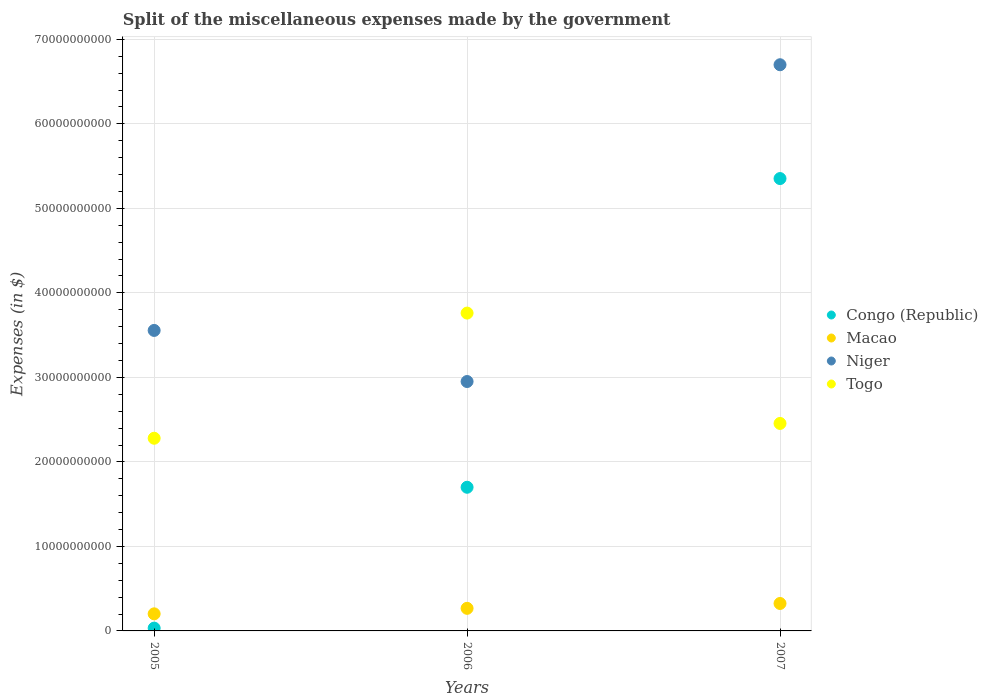How many different coloured dotlines are there?
Offer a very short reply. 4. Is the number of dotlines equal to the number of legend labels?
Give a very brief answer. Yes. What is the miscellaneous expenses made by the government in Macao in 2005?
Your answer should be very brief. 2.02e+09. Across all years, what is the maximum miscellaneous expenses made by the government in Niger?
Ensure brevity in your answer.  6.70e+1. Across all years, what is the minimum miscellaneous expenses made by the government in Congo (Republic)?
Ensure brevity in your answer.  3.32e+08. What is the total miscellaneous expenses made by the government in Niger in the graph?
Give a very brief answer. 1.32e+11. What is the difference between the miscellaneous expenses made by the government in Macao in 2005 and that in 2007?
Your answer should be compact. -1.23e+09. What is the difference between the miscellaneous expenses made by the government in Niger in 2005 and the miscellaneous expenses made by the government in Togo in 2007?
Provide a short and direct response. 1.10e+1. What is the average miscellaneous expenses made by the government in Niger per year?
Give a very brief answer. 4.40e+1. In the year 2006, what is the difference between the miscellaneous expenses made by the government in Macao and miscellaneous expenses made by the government in Togo?
Your response must be concise. -3.49e+1. What is the ratio of the miscellaneous expenses made by the government in Togo in 2006 to that in 2007?
Offer a terse response. 1.53. Is the difference between the miscellaneous expenses made by the government in Macao in 2005 and 2006 greater than the difference between the miscellaneous expenses made by the government in Togo in 2005 and 2006?
Provide a succinct answer. Yes. What is the difference between the highest and the second highest miscellaneous expenses made by the government in Congo (Republic)?
Ensure brevity in your answer.  3.65e+1. What is the difference between the highest and the lowest miscellaneous expenses made by the government in Togo?
Provide a short and direct response. 1.48e+1. Is it the case that in every year, the sum of the miscellaneous expenses made by the government in Congo (Republic) and miscellaneous expenses made by the government in Niger  is greater than the sum of miscellaneous expenses made by the government in Togo and miscellaneous expenses made by the government in Macao?
Provide a succinct answer. No. Is it the case that in every year, the sum of the miscellaneous expenses made by the government in Togo and miscellaneous expenses made by the government in Niger  is greater than the miscellaneous expenses made by the government in Congo (Republic)?
Offer a very short reply. Yes. Is the miscellaneous expenses made by the government in Niger strictly greater than the miscellaneous expenses made by the government in Congo (Republic) over the years?
Your answer should be very brief. Yes. Is the miscellaneous expenses made by the government in Niger strictly less than the miscellaneous expenses made by the government in Macao over the years?
Keep it short and to the point. No. How many years are there in the graph?
Keep it short and to the point. 3. What is the difference between two consecutive major ticks on the Y-axis?
Ensure brevity in your answer.  1.00e+1. Where does the legend appear in the graph?
Keep it short and to the point. Center right. How are the legend labels stacked?
Your response must be concise. Vertical. What is the title of the graph?
Provide a short and direct response. Split of the miscellaneous expenses made by the government. What is the label or title of the Y-axis?
Your answer should be very brief. Expenses (in $). What is the Expenses (in $) of Congo (Republic) in 2005?
Offer a terse response. 3.32e+08. What is the Expenses (in $) of Macao in 2005?
Keep it short and to the point. 2.02e+09. What is the Expenses (in $) in Niger in 2005?
Offer a very short reply. 3.56e+1. What is the Expenses (in $) of Togo in 2005?
Ensure brevity in your answer.  2.28e+1. What is the Expenses (in $) of Congo (Republic) in 2006?
Provide a short and direct response. 1.70e+1. What is the Expenses (in $) of Macao in 2006?
Your answer should be very brief. 2.67e+09. What is the Expenses (in $) of Niger in 2006?
Your answer should be compact. 2.95e+1. What is the Expenses (in $) of Togo in 2006?
Your response must be concise. 3.76e+1. What is the Expenses (in $) in Congo (Republic) in 2007?
Your answer should be very brief. 5.35e+1. What is the Expenses (in $) in Macao in 2007?
Make the answer very short. 3.25e+09. What is the Expenses (in $) in Niger in 2007?
Make the answer very short. 6.70e+1. What is the Expenses (in $) in Togo in 2007?
Provide a short and direct response. 2.46e+1. Across all years, what is the maximum Expenses (in $) in Congo (Republic)?
Your answer should be very brief. 5.35e+1. Across all years, what is the maximum Expenses (in $) in Macao?
Give a very brief answer. 3.25e+09. Across all years, what is the maximum Expenses (in $) in Niger?
Your answer should be very brief. 6.70e+1. Across all years, what is the maximum Expenses (in $) of Togo?
Provide a short and direct response. 3.76e+1. Across all years, what is the minimum Expenses (in $) of Congo (Republic)?
Your response must be concise. 3.32e+08. Across all years, what is the minimum Expenses (in $) of Macao?
Your answer should be compact. 2.02e+09. Across all years, what is the minimum Expenses (in $) in Niger?
Offer a very short reply. 2.95e+1. Across all years, what is the minimum Expenses (in $) in Togo?
Ensure brevity in your answer.  2.28e+1. What is the total Expenses (in $) of Congo (Republic) in the graph?
Make the answer very short. 7.09e+1. What is the total Expenses (in $) in Macao in the graph?
Your answer should be very brief. 7.94e+09. What is the total Expenses (in $) of Niger in the graph?
Provide a short and direct response. 1.32e+11. What is the total Expenses (in $) of Togo in the graph?
Your response must be concise. 8.50e+1. What is the difference between the Expenses (in $) in Congo (Republic) in 2005 and that in 2006?
Your response must be concise. -1.67e+1. What is the difference between the Expenses (in $) in Macao in 2005 and that in 2006?
Your response must be concise. -6.51e+08. What is the difference between the Expenses (in $) in Niger in 2005 and that in 2006?
Provide a succinct answer. 6.05e+09. What is the difference between the Expenses (in $) of Togo in 2005 and that in 2006?
Provide a short and direct response. -1.48e+1. What is the difference between the Expenses (in $) of Congo (Republic) in 2005 and that in 2007?
Your answer should be compact. -5.32e+1. What is the difference between the Expenses (in $) in Macao in 2005 and that in 2007?
Offer a very short reply. -1.23e+09. What is the difference between the Expenses (in $) in Niger in 2005 and that in 2007?
Make the answer very short. -3.14e+1. What is the difference between the Expenses (in $) in Togo in 2005 and that in 2007?
Keep it short and to the point. -1.75e+09. What is the difference between the Expenses (in $) of Congo (Republic) in 2006 and that in 2007?
Keep it short and to the point. -3.65e+1. What is the difference between the Expenses (in $) in Macao in 2006 and that in 2007?
Your response must be concise. -5.74e+08. What is the difference between the Expenses (in $) in Niger in 2006 and that in 2007?
Your answer should be very brief. -3.75e+1. What is the difference between the Expenses (in $) of Togo in 2006 and that in 2007?
Offer a terse response. 1.31e+1. What is the difference between the Expenses (in $) in Congo (Republic) in 2005 and the Expenses (in $) in Macao in 2006?
Provide a succinct answer. -2.34e+09. What is the difference between the Expenses (in $) in Congo (Republic) in 2005 and the Expenses (in $) in Niger in 2006?
Ensure brevity in your answer.  -2.92e+1. What is the difference between the Expenses (in $) of Congo (Republic) in 2005 and the Expenses (in $) of Togo in 2006?
Your response must be concise. -3.73e+1. What is the difference between the Expenses (in $) in Macao in 2005 and the Expenses (in $) in Niger in 2006?
Your response must be concise. -2.75e+1. What is the difference between the Expenses (in $) of Macao in 2005 and the Expenses (in $) of Togo in 2006?
Your answer should be very brief. -3.56e+1. What is the difference between the Expenses (in $) of Niger in 2005 and the Expenses (in $) of Togo in 2006?
Keep it short and to the point. -2.05e+09. What is the difference between the Expenses (in $) in Congo (Republic) in 2005 and the Expenses (in $) in Macao in 2007?
Keep it short and to the point. -2.91e+09. What is the difference between the Expenses (in $) in Congo (Republic) in 2005 and the Expenses (in $) in Niger in 2007?
Offer a very short reply. -6.67e+1. What is the difference between the Expenses (in $) in Congo (Republic) in 2005 and the Expenses (in $) in Togo in 2007?
Make the answer very short. -2.42e+1. What is the difference between the Expenses (in $) in Macao in 2005 and the Expenses (in $) in Niger in 2007?
Make the answer very short. -6.50e+1. What is the difference between the Expenses (in $) in Macao in 2005 and the Expenses (in $) in Togo in 2007?
Offer a terse response. -2.25e+1. What is the difference between the Expenses (in $) of Niger in 2005 and the Expenses (in $) of Togo in 2007?
Provide a short and direct response. 1.10e+1. What is the difference between the Expenses (in $) in Congo (Republic) in 2006 and the Expenses (in $) in Macao in 2007?
Provide a short and direct response. 1.38e+1. What is the difference between the Expenses (in $) of Congo (Republic) in 2006 and the Expenses (in $) of Niger in 2007?
Your answer should be compact. -5.00e+1. What is the difference between the Expenses (in $) of Congo (Republic) in 2006 and the Expenses (in $) of Togo in 2007?
Offer a very short reply. -7.55e+09. What is the difference between the Expenses (in $) of Macao in 2006 and the Expenses (in $) of Niger in 2007?
Make the answer very short. -6.43e+1. What is the difference between the Expenses (in $) in Macao in 2006 and the Expenses (in $) in Togo in 2007?
Give a very brief answer. -2.19e+1. What is the difference between the Expenses (in $) of Niger in 2006 and the Expenses (in $) of Togo in 2007?
Give a very brief answer. 4.96e+09. What is the average Expenses (in $) of Congo (Republic) per year?
Your answer should be compact. 2.36e+1. What is the average Expenses (in $) of Macao per year?
Your answer should be compact. 2.65e+09. What is the average Expenses (in $) in Niger per year?
Offer a terse response. 4.40e+1. What is the average Expenses (in $) of Togo per year?
Ensure brevity in your answer.  2.83e+1. In the year 2005, what is the difference between the Expenses (in $) in Congo (Republic) and Expenses (in $) in Macao?
Keep it short and to the point. -1.69e+09. In the year 2005, what is the difference between the Expenses (in $) in Congo (Republic) and Expenses (in $) in Niger?
Offer a terse response. -3.52e+1. In the year 2005, what is the difference between the Expenses (in $) of Congo (Republic) and Expenses (in $) of Togo?
Keep it short and to the point. -2.25e+1. In the year 2005, what is the difference between the Expenses (in $) of Macao and Expenses (in $) of Niger?
Keep it short and to the point. -3.35e+1. In the year 2005, what is the difference between the Expenses (in $) of Macao and Expenses (in $) of Togo?
Make the answer very short. -2.08e+1. In the year 2005, what is the difference between the Expenses (in $) in Niger and Expenses (in $) in Togo?
Give a very brief answer. 1.28e+1. In the year 2006, what is the difference between the Expenses (in $) in Congo (Republic) and Expenses (in $) in Macao?
Give a very brief answer. 1.43e+1. In the year 2006, what is the difference between the Expenses (in $) of Congo (Republic) and Expenses (in $) of Niger?
Provide a short and direct response. -1.25e+1. In the year 2006, what is the difference between the Expenses (in $) in Congo (Republic) and Expenses (in $) in Togo?
Ensure brevity in your answer.  -2.06e+1. In the year 2006, what is the difference between the Expenses (in $) in Macao and Expenses (in $) in Niger?
Your response must be concise. -2.68e+1. In the year 2006, what is the difference between the Expenses (in $) of Macao and Expenses (in $) of Togo?
Provide a succinct answer. -3.49e+1. In the year 2006, what is the difference between the Expenses (in $) of Niger and Expenses (in $) of Togo?
Your answer should be compact. -8.10e+09. In the year 2007, what is the difference between the Expenses (in $) in Congo (Republic) and Expenses (in $) in Macao?
Keep it short and to the point. 5.03e+1. In the year 2007, what is the difference between the Expenses (in $) of Congo (Republic) and Expenses (in $) of Niger?
Ensure brevity in your answer.  -1.35e+1. In the year 2007, what is the difference between the Expenses (in $) of Congo (Republic) and Expenses (in $) of Togo?
Give a very brief answer. 2.90e+1. In the year 2007, what is the difference between the Expenses (in $) in Macao and Expenses (in $) in Niger?
Provide a short and direct response. -6.38e+1. In the year 2007, what is the difference between the Expenses (in $) of Macao and Expenses (in $) of Togo?
Give a very brief answer. -2.13e+1. In the year 2007, what is the difference between the Expenses (in $) of Niger and Expenses (in $) of Togo?
Your response must be concise. 4.24e+1. What is the ratio of the Expenses (in $) in Congo (Republic) in 2005 to that in 2006?
Make the answer very short. 0.02. What is the ratio of the Expenses (in $) in Macao in 2005 to that in 2006?
Provide a succinct answer. 0.76. What is the ratio of the Expenses (in $) of Niger in 2005 to that in 2006?
Offer a very short reply. 1.2. What is the ratio of the Expenses (in $) in Togo in 2005 to that in 2006?
Provide a succinct answer. 0.61. What is the ratio of the Expenses (in $) of Congo (Republic) in 2005 to that in 2007?
Your response must be concise. 0.01. What is the ratio of the Expenses (in $) of Macao in 2005 to that in 2007?
Ensure brevity in your answer.  0.62. What is the ratio of the Expenses (in $) in Niger in 2005 to that in 2007?
Your answer should be very brief. 0.53. What is the ratio of the Expenses (in $) in Togo in 2005 to that in 2007?
Offer a very short reply. 0.93. What is the ratio of the Expenses (in $) in Congo (Republic) in 2006 to that in 2007?
Give a very brief answer. 0.32. What is the ratio of the Expenses (in $) in Macao in 2006 to that in 2007?
Offer a terse response. 0.82. What is the ratio of the Expenses (in $) of Niger in 2006 to that in 2007?
Offer a terse response. 0.44. What is the ratio of the Expenses (in $) of Togo in 2006 to that in 2007?
Make the answer very short. 1.53. What is the difference between the highest and the second highest Expenses (in $) of Congo (Republic)?
Make the answer very short. 3.65e+1. What is the difference between the highest and the second highest Expenses (in $) of Macao?
Your answer should be compact. 5.74e+08. What is the difference between the highest and the second highest Expenses (in $) in Niger?
Provide a succinct answer. 3.14e+1. What is the difference between the highest and the second highest Expenses (in $) in Togo?
Provide a succinct answer. 1.31e+1. What is the difference between the highest and the lowest Expenses (in $) in Congo (Republic)?
Give a very brief answer. 5.32e+1. What is the difference between the highest and the lowest Expenses (in $) in Macao?
Provide a succinct answer. 1.23e+09. What is the difference between the highest and the lowest Expenses (in $) in Niger?
Keep it short and to the point. 3.75e+1. What is the difference between the highest and the lowest Expenses (in $) in Togo?
Give a very brief answer. 1.48e+1. 